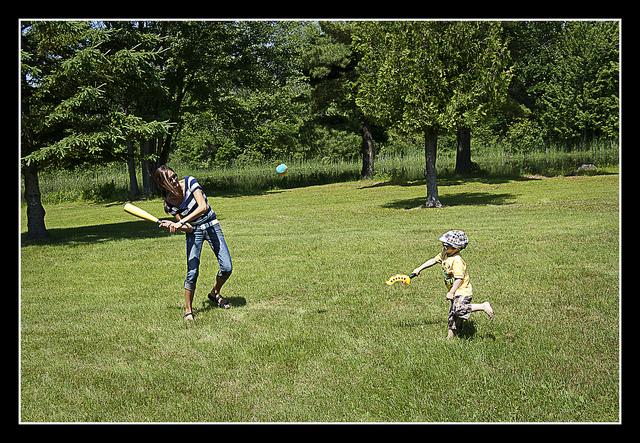What is the person on the left holding?
Concise answer only. Bat. What sport is the woman teaching the young boy?
Keep it brief. Baseball. What kind of tree is behind the woman?
Short answer required. Oak. 